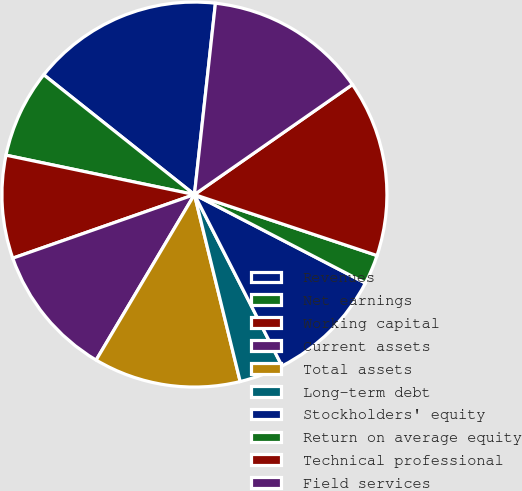Convert chart to OTSL. <chart><loc_0><loc_0><loc_500><loc_500><pie_chart><fcel>Revenues<fcel>Net earnings<fcel>Working capital<fcel>Current assets<fcel>Total assets<fcel>Long-term debt<fcel>Stockholders' equity<fcel>Return on average equity<fcel>Technical professional<fcel>Field services<nl><fcel>16.05%<fcel>7.41%<fcel>8.64%<fcel>11.11%<fcel>12.35%<fcel>3.7%<fcel>9.88%<fcel>2.47%<fcel>14.81%<fcel>13.58%<nl></chart> 